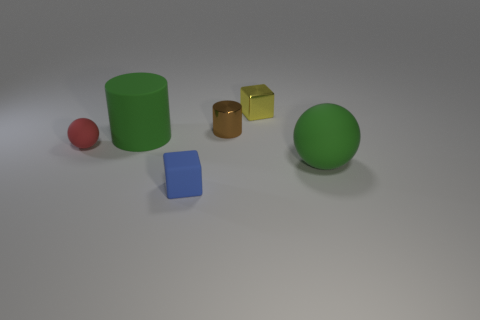There is a big green object that is the same shape as the tiny red matte object; what is it made of?
Ensure brevity in your answer.  Rubber. What number of rubber cylinders have the same size as the brown shiny thing?
Keep it short and to the point. 0. What is the color of the other tiny object that is the same material as the tiny blue object?
Give a very brief answer. Red. Is the number of rubber objects less than the number of purple shiny objects?
Make the answer very short. No. How many red things are either tiny shiny blocks or small things?
Provide a succinct answer. 1. What number of spheres are to the right of the small cylinder and on the left side of the green cylinder?
Your response must be concise. 0. Is the material of the tiny blue block the same as the red sphere?
Provide a short and direct response. Yes. There is another metallic thing that is the same size as the yellow metal thing; what is its shape?
Your answer should be compact. Cylinder. Is the number of small purple spheres greater than the number of tiny brown metal cylinders?
Give a very brief answer. No. There is a thing that is on the left side of the large rubber ball and in front of the red rubber sphere; what material is it made of?
Make the answer very short. Rubber. 